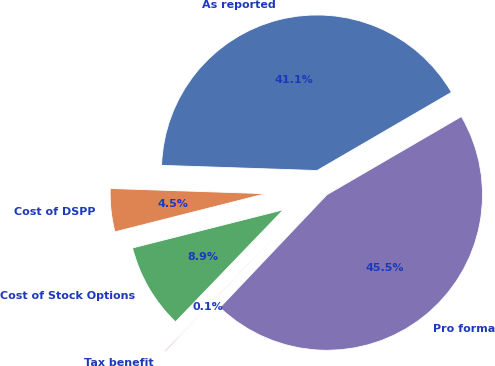Convert chart to OTSL. <chart><loc_0><loc_0><loc_500><loc_500><pie_chart><fcel>As reported<fcel>Cost of DSPP<fcel>Cost of Stock Options<fcel>Tax benefit<fcel>Pro forma<nl><fcel>41.09%<fcel>4.48%<fcel>8.86%<fcel>0.11%<fcel>45.47%<nl></chart> 